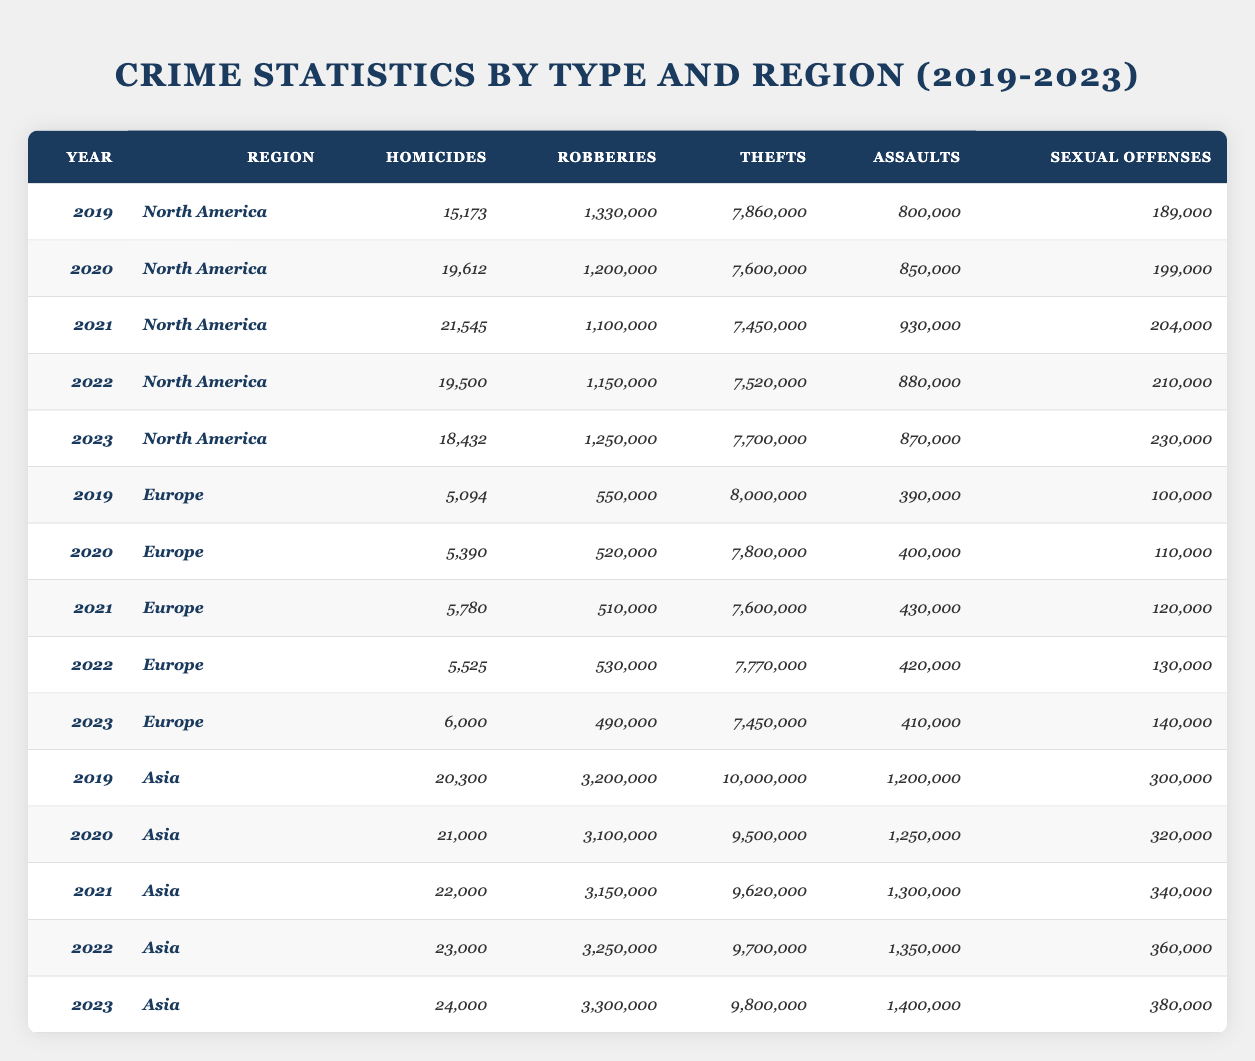What was the total number of homicides in North America from 2019 to 2023? To find the total number of homicides in North America from 2019 to 2023, I need to sum the values for each year: 15,173 + 19,612 + 21,545 + 19,500 + 18,432 = 94,262.
Answer: 94,262 Which region had the highest number of robberies in 2021? By looking at the robberies for each region in 2021, North America had 1,100,000, Europe had 510,000, and Asia had 3,150,000. Comparing these values, Asia had the highest at 3,150,000.
Answer: Asia What was the percentage decrease in sexual offenses in Europe from 2020 to 2023? To calculate the percentage decrease, find the difference in sexual offenses: 110,000 (2020) - 140,000 (2023) = -30,000. Divide that by the 2020 value, then multiply by 100: (-30,000 / 110,000) * 100 = -27.27%.
Answer: -27.27% Did the total number of assaults in Asia increase each year from 2019 to 2023? The total assaults in Asia for each year are: 1,200,000 (2019), 1,250,000 (2020), 1,300,000 (2021), 1,350,000 (2022), and 1,400,000 (2023). Since each subsequent year had a greater number than the previous, the number of assaults did indeed increase each year.
Answer: Yes What is the average number of thefts in North America over the five-year period? Summing the thefts for North America from 2019 to 2023 gives: 7,860,000 + 7,600,000 + 7,450,000 + 7,520,000 + 7,700,000 = 38,130,000. There are 5 years, so averaging that gives: 38,130,000 / 5 = 7,626,000.
Answer: 7,626,000 Which year had the lowest number of homicides in Europe? Reviewing the homicides in Europe, the values are: 5,094 (2019), 5,390 (2020), 5,780 (2021), 5,525 (2022), and 6,000 (2023). The lowest is 5,094 in 2019.
Answer: 2019 What was the increase in thefts in Asia from 2019 to 2023? The number of thefts in Asia were: 10,000,000 (2019) and 9,800,000 (2023). The increase can be calculated as 9,800,000 - 10,000,000 = -200,000. Since it is a decrease, I state that there was no increase.
Answer: No increase How does the total number of sexual offenses in North America compare to Europe in 2022? The total number of sexual offenses in North America in 2022 was 210,000, while for Europe it was 130,000. Since 210,000 is greater than 130,000, North America had more sexual offenses.
Answer: North America had more sexual offenses What was the average number of robberies in Europe during the five years? The robberies in Europe are 550,000 (2019), 520,000 (2020), 510,000 (2021), 530,000 (2022), and 490,000 (2023). Summing gives: 550,000 + 520,000 + 510,000 + 530,000 + 490,000 = 2,600,000. To find the average, divide by 5: 2,600,000 / 5 = 520,000.
Answer: 520,000 What year had the highest number of homicides in Asia? The number of homicides in Asia for the years 2019 to 2023 are: 20,300 (2019), 21,000 (2020), 22,000 (2021), 23,000 (2022), and 24,000 (2023). The highest was 24,000 in 2023.
Answer: 2023 